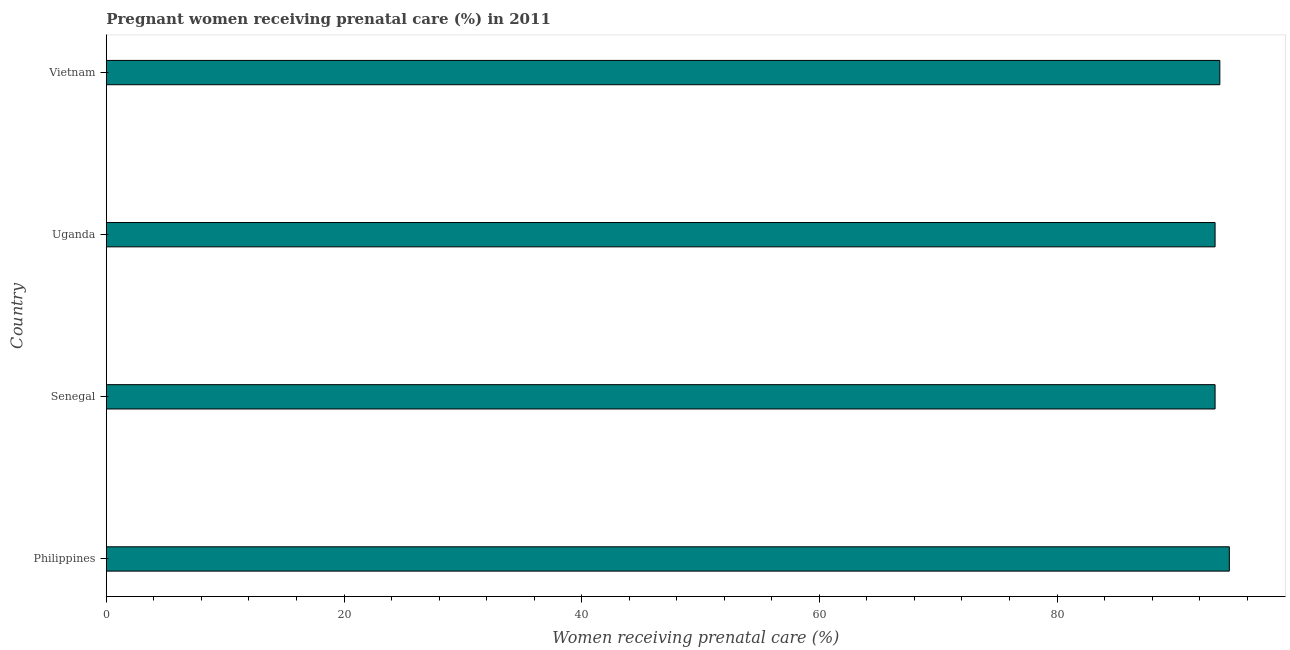What is the title of the graph?
Your answer should be very brief. Pregnant women receiving prenatal care (%) in 2011. What is the label or title of the X-axis?
Give a very brief answer. Women receiving prenatal care (%). What is the percentage of pregnant women receiving prenatal care in Vietnam?
Offer a terse response. 93.7. Across all countries, what is the maximum percentage of pregnant women receiving prenatal care?
Offer a very short reply. 94.5. Across all countries, what is the minimum percentage of pregnant women receiving prenatal care?
Keep it short and to the point. 93.3. In which country was the percentage of pregnant women receiving prenatal care maximum?
Provide a succinct answer. Philippines. In which country was the percentage of pregnant women receiving prenatal care minimum?
Ensure brevity in your answer.  Senegal. What is the sum of the percentage of pregnant women receiving prenatal care?
Keep it short and to the point. 374.8. What is the average percentage of pregnant women receiving prenatal care per country?
Your response must be concise. 93.7. What is the median percentage of pregnant women receiving prenatal care?
Your answer should be very brief. 93.5. What is the ratio of the percentage of pregnant women receiving prenatal care in Philippines to that in Uganda?
Provide a succinct answer. 1.01. Is the percentage of pregnant women receiving prenatal care in Senegal less than that in Vietnam?
Make the answer very short. Yes. Is the difference between the percentage of pregnant women receiving prenatal care in Philippines and Vietnam greater than the difference between any two countries?
Your response must be concise. No. Is the sum of the percentage of pregnant women receiving prenatal care in Philippines and Uganda greater than the maximum percentage of pregnant women receiving prenatal care across all countries?
Your answer should be very brief. Yes. What is the difference between the highest and the lowest percentage of pregnant women receiving prenatal care?
Provide a short and direct response. 1.2. In how many countries, is the percentage of pregnant women receiving prenatal care greater than the average percentage of pregnant women receiving prenatal care taken over all countries?
Offer a very short reply. 1. How many bars are there?
Provide a succinct answer. 4. How many countries are there in the graph?
Your answer should be compact. 4. Are the values on the major ticks of X-axis written in scientific E-notation?
Keep it short and to the point. No. What is the Women receiving prenatal care (%) in Philippines?
Provide a short and direct response. 94.5. What is the Women receiving prenatal care (%) in Senegal?
Your answer should be very brief. 93.3. What is the Women receiving prenatal care (%) of Uganda?
Your answer should be very brief. 93.3. What is the Women receiving prenatal care (%) in Vietnam?
Provide a succinct answer. 93.7. What is the difference between the Women receiving prenatal care (%) in Philippines and Vietnam?
Your answer should be compact. 0.8. What is the difference between the Women receiving prenatal care (%) in Senegal and Uganda?
Provide a short and direct response. 0. What is the ratio of the Women receiving prenatal care (%) in Philippines to that in Senegal?
Give a very brief answer. 1.01. What is the ratio of the Women receiving prenatal care (%) in Senegal to that in Uganda?
Make the answer very short. 1. What is the ratio of the Women receiving prenatal care (%) in Uganda to that in Vietnam?
Your answer should be compact. 1. 